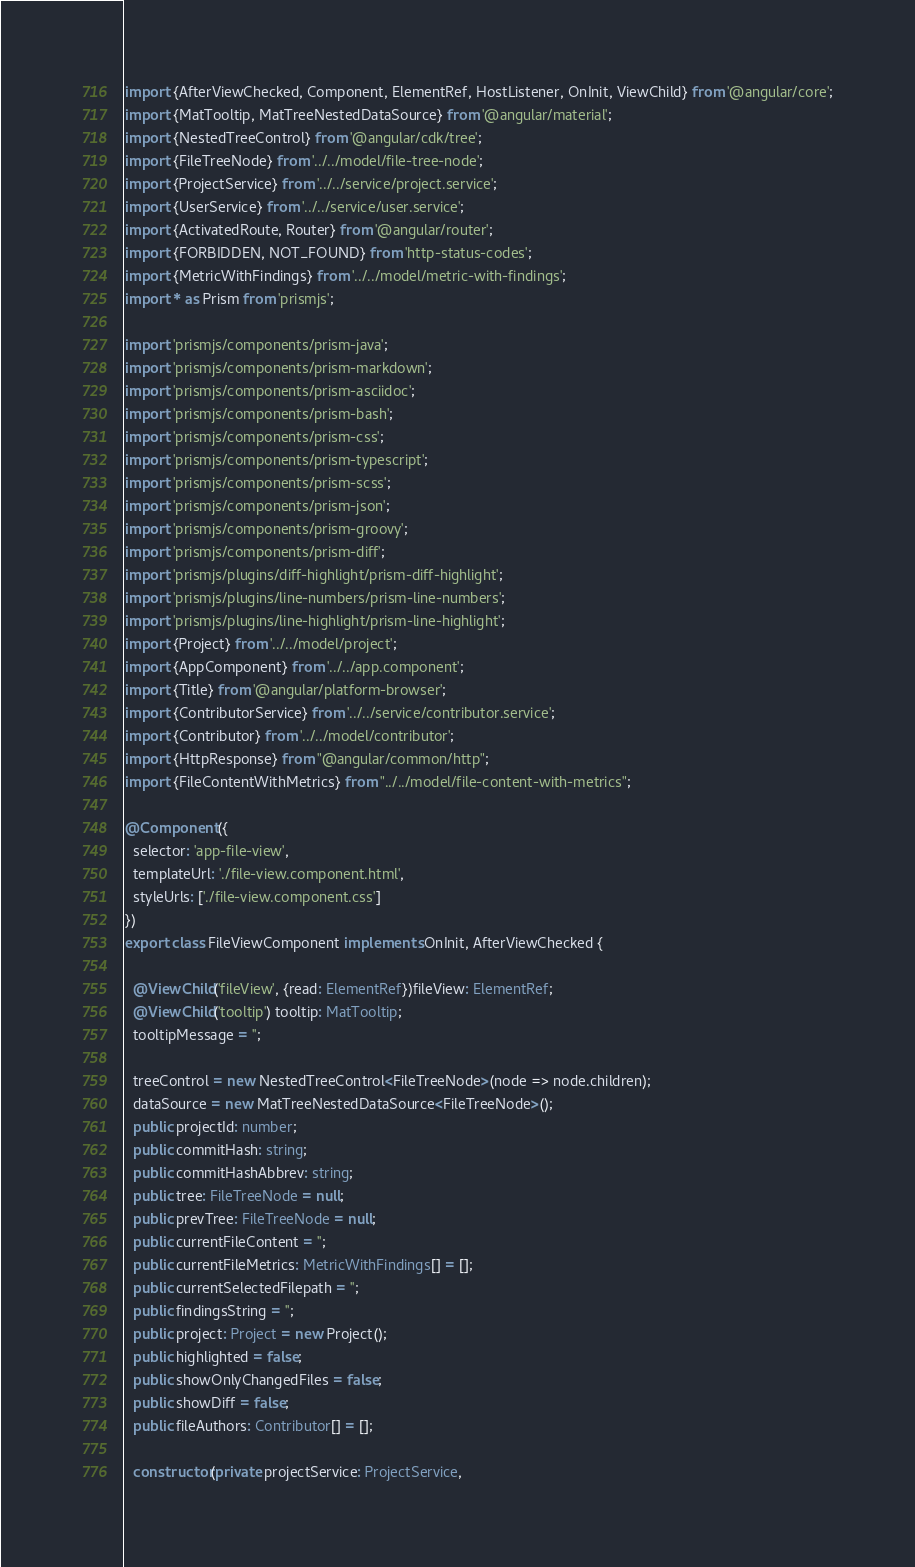Convert code to text. <code><loc_0><loc_0><loc_500><loc_500><_TypeScript_>import {AfterViewChecked, Component, ElementRef, HostListener, OnInit, ViewChild} from '@angular/core';
import {MatTooltip, MatTreeNestedDataSource} from '@angular/material';
import {NestedTreeControl} from '@angular/cdk/tree';
import {FileTreeNode} from '../../model/file-tree-node';
import {ProjectService} from '../../service/project.service';
import {UserService} from '../../service/user.service';
import {ActivatedRoute, Router} from '@angular/router';
import {FORBIDDEN, NOT_FOUND} from 'http-status-codes';
import {MetricWithFindings} from '../../model/metric-with-findings';
import * as Prism from 'prismjs';

import 'prismjs/components/prism-java';
import 'prismjs/components/prism-markdown';
import 'prismjs/components/prism-asciidoc';
import 'prismjs/components/prism-bash';
import 'prismjs/components/prism-css';
import 'prismjs/components/prism-typescript';
import 'prismjs/components/prism-scss';
import 'prismjs/components/prism-json';
import 'prismjs/components/prism-groovy';
import 'prismjs/components/prism-diff';
import 'prismjs/plugins/diff-highlight/prism-diff-highlight';
import 'prismjs/plugins/line-numbers/prism-line-numbers';
import 'prismjs/plugins/line-highlight/prism-line-highlight';
import {Project} from '../../model/project';
import {AppComponent} from '../../app.component';
import {Title} from '@angular/platform-browser';
import {ContributorService} from '../../service/contributor.service';
import {Contributor} from '../../model/contributor';
import {HttpResponse} from "@angular/common/http";
import {FileContentWithMetrics} from "../../model/file-content-with-metrics";

@Component({
  selector: 'app-file-view',
  templateUrl: './file-view.component.html',
  styleUrls: ['./file-view.component.css']
})
export class FileViewComponent implements OnInit, AfterViewChecked {

  @ViewChild('fileView', {read: ElementRef})fileView: ElementRef;
  @ViewChild('tooltip') tooltip: MatTooltip;
  tooltipMessage = '';

  treeControl = new NestedTreeControl<FileTreeNode>(node => node.children);
  dataSource = new MatTreeNestedDataSource<FileTreeNode>();
  public projectId: number;
  public commitHash: string;
  public commitHashAbbrev: string;
  public tree: FileTreeNode = null;
  public prevTree: FileTreeNode = null;
  public currentFileContent = '';
  public currentFileMetrics: MetricWithFindings[] = [];
  public currentSelectedFilepath = '';
  public findingsString = '';
  public project: Project = new Project();
  public highlighted = false;
  public showOnlyChangedFiles = false;
  public showDiff = false;
  public fileAuthors: Contributor[] = [];

  constructor(private projectService: ProjectService,</code> 